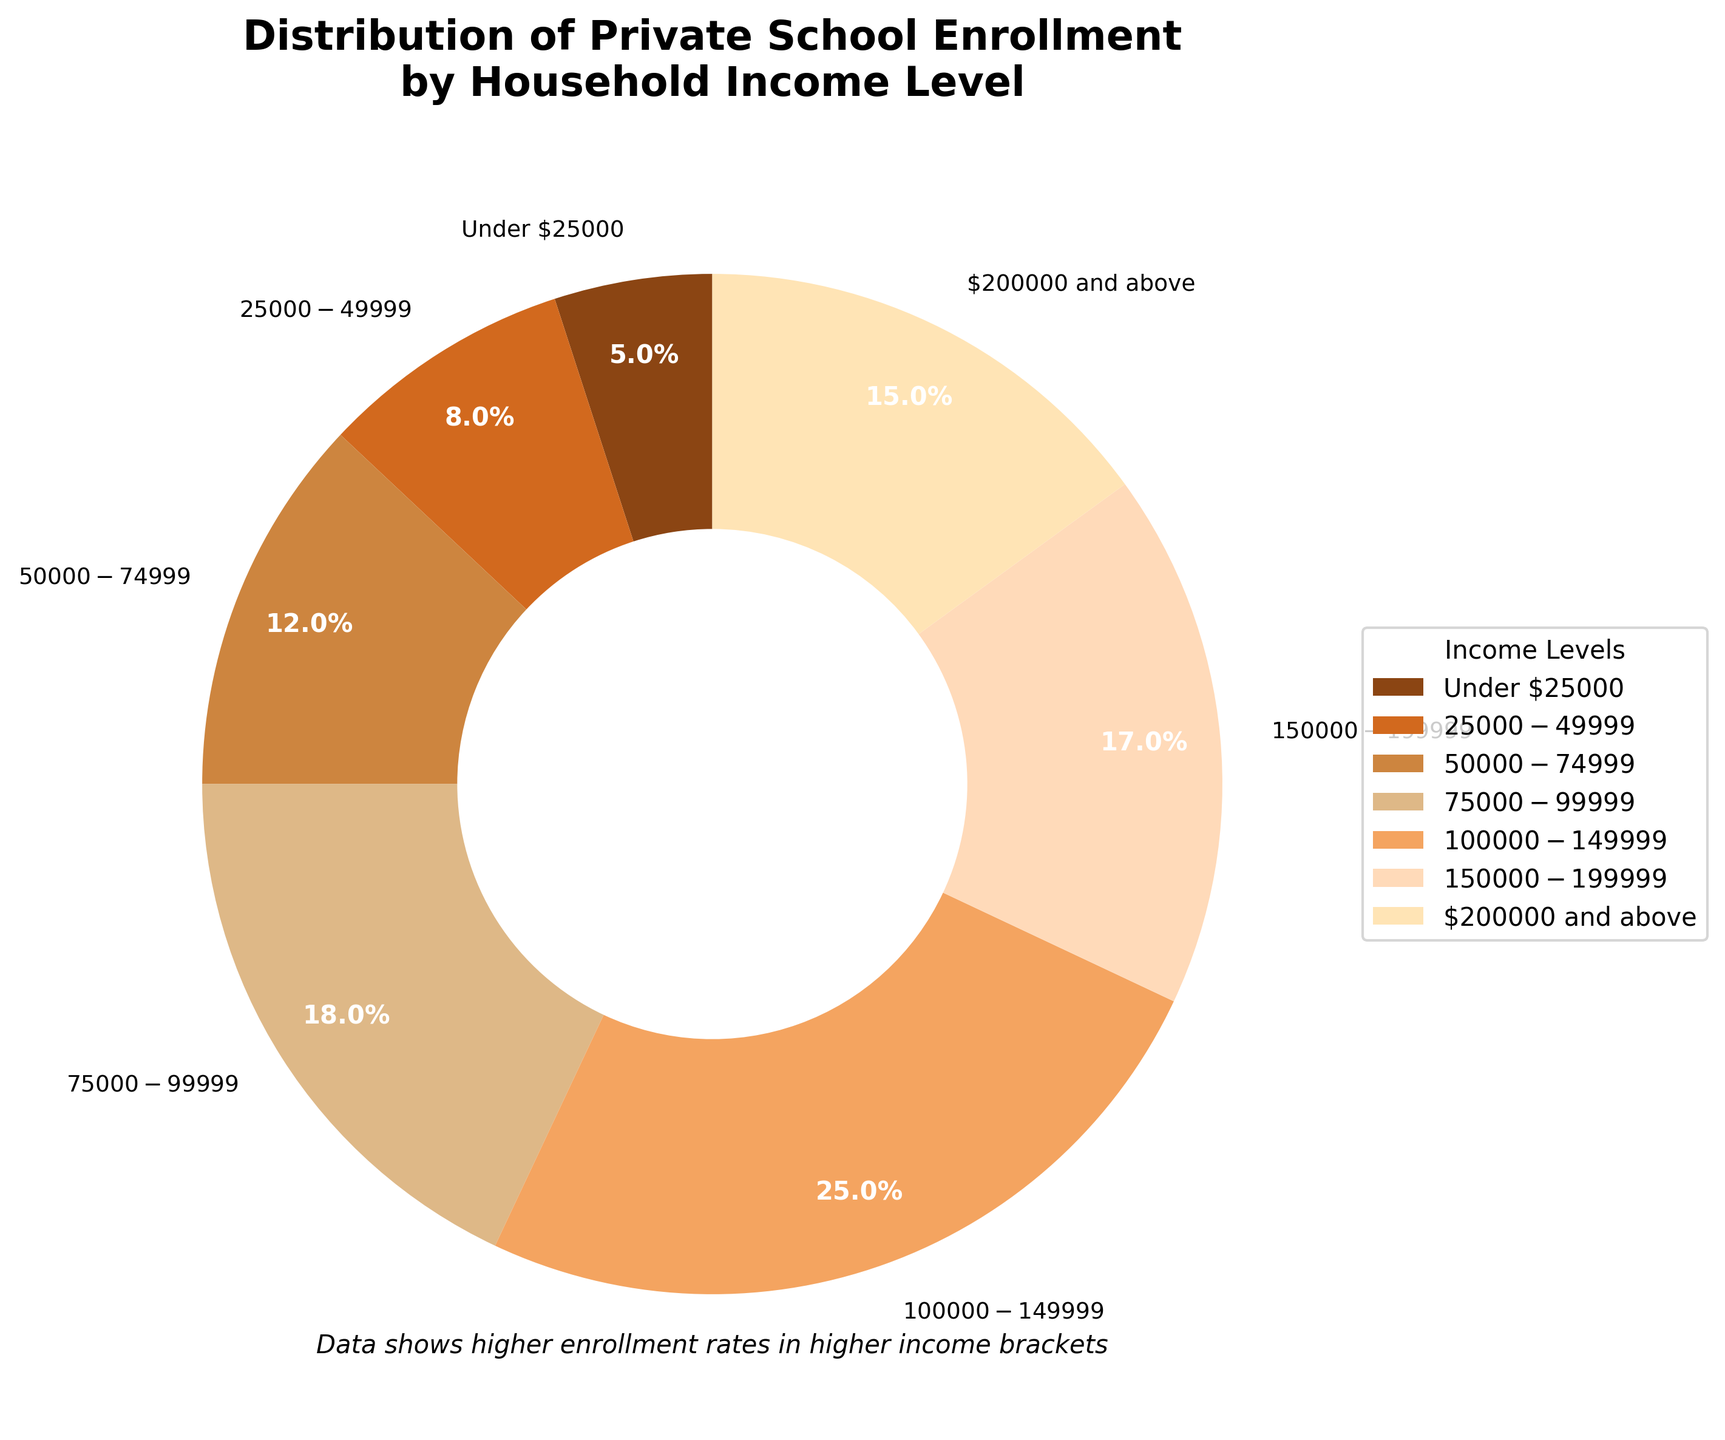Which household income level has the highest percentage of private school enrollment? First, observe the different segments in the pie chart. The size of the segment with the most substantial share represents the income level with the highest percentage. That would be the $100,000-$149,999 segment.
Answer: $100,000-$149,999 What's the total percentage of private school enrollment for households earning below $50,000? Identify the segments for income levels under $25,000 and $25,000-$49,999. Add their percentages: 5% (under $25,000) + 8% ($25,000-$49,999) = 13%.
Answer: 13% Does any income level segment contribute exactly 12% to private school enrollment? Look at each segment and find the one labeled with 12%. This segment corresponds to the $50,000-$74,999 income level.
Answer: $50,000-$74,999 Which income level range has a higher percentage of private school enrollment: $150,000-$199,999 or $200,000 and above? Compare the sizes of the segments for $150,000-$199,999 (17%) and $200,000 and above (15%). The $150,000-$199,999 segment is higher.
Answer: $150,000-$199,999 What is the difference in private school enrollment percentages between the lowest and highest income brackets? Subtract the percentage of the "Under $25,000" segment (5%) from the "$100,000-$149,999" segment (25%). 25% - 5% = 20%.
Answer: 20% Which income levels combined contribute to nearly 50% of the private school enrollment? Look for segments that sum close to 50%. The $100,000-$149,999 (25%) and $75,000-$99,999 (18%) together make 43%, and adding $200,000 and above (15%) gives a total of 58%, which is the closest and above 50%.
Answer: $100,000-$149,999, $75,000-$99,999, $200,000 and above Which income level groups have nearly the same percentage of enrollment? Look at segments with similar percentages. The $150,000-$199,999 (17%) and $200,000 and above (15%) segments have similar percentages.
Answer: $150,000-$199,999 and $200,000 and above What percentage of private school enrollment is represented by households earning $75,000 - $199,999 combined? Add the segments: $75,000-$99,999 (18%), $100,000-$149,999 (25%), and $150,000-$199,999 (17%). 18% + 25% + 17% = 60%.
Answer: 60% How does the percentage of households earning $25,000-$49,999 compare to those earning under $25,000? Compare the segments: $25,000-$49,999 (8%) is larger than under $25,000 (5%).
Answer: Higher In which segments do the colors transition from darker to lighter shades? Observe the color transitions in segments: the progression from the darkest color in the under $25,000 segment to the lightest in the $200,000 and above segment.
Answer: From under $25,000 to $200,000 and above 